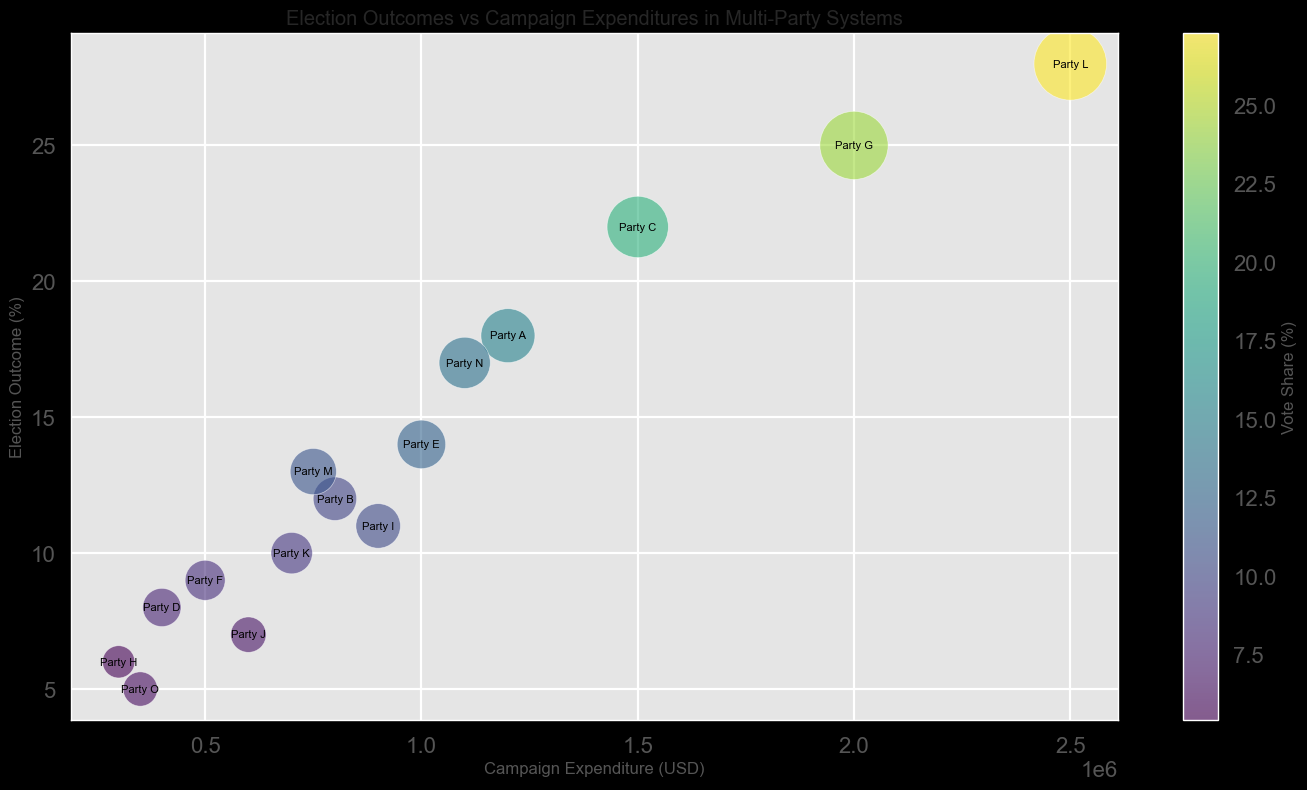What is the vote share of Party G? Locate Party G in the plot, and observe the size and color of its bubble. The color bar indicates the vote share percentage represented by each bubble's color. Match the color of Party G's bubble to the color bar.
Answer: 24.1% Which party had the highest campaign expenditure? Look at the x-axis representing campaign expenditure and identify the bubble positioned furthest to the right. That party has the highest expenditure.
Answer: Party L How much more did Party C spend compared to Party B? Identify the x-axis positions of Party C and Party B to get their expenditures, which are 1,500,000 and 800,000 respectively. Subtract the expenditure of Party B from Party C.
Answer: 700,000 Which party received the lowest election outcome? Look at the y-axis representing election outcomes and identify the bubble positioned lowest on this axis. That party received the lowest election outcome.
Answer: Party O What is the average vote share of parties that spent more than 1,000,000 USD? Identify the parties with expenditures greater than 1,000,000 USD (Parties A, C, G, L, N). Find their vote shares, add them up (15.1 + 19.5 + 24.1 + 27.3 + 13.6) and divide by the number of parties (5).
Answer: 19.92% Which party had a greater election outcome, Party F or Party H? Locate the vertical positions of Party F and Party H on the y-axis. The one positioned higher received the greater election outcome.
Answer: Party F What is the difference in vote share between Party M and Party J? Identify the colors corresponding to Party M and Party J on the color bar, and find their vote shares (11.1 for Party M and 6.5 for Party J). Subtract these values.
Answer: 4.6 Which party is represented by the yellowish bubble? Find the bubble with the yellowish color and match it with the corresponding party label in the plot.
Answer: Party G What is the sum of election outcomes for Parties D, E, and F? Identify the vertical positions on the y-axis for Parties D, E, and F. Add up their election outcomes (8 + 14 + 9).
Answer: 31 Are there any parties with the same election outcome? If so, which ones? Examine the y-axis positions of all bubbles to see if any align at the same height. If they align, note the corresponding parties.
Answer: No, all outcomes are unique 